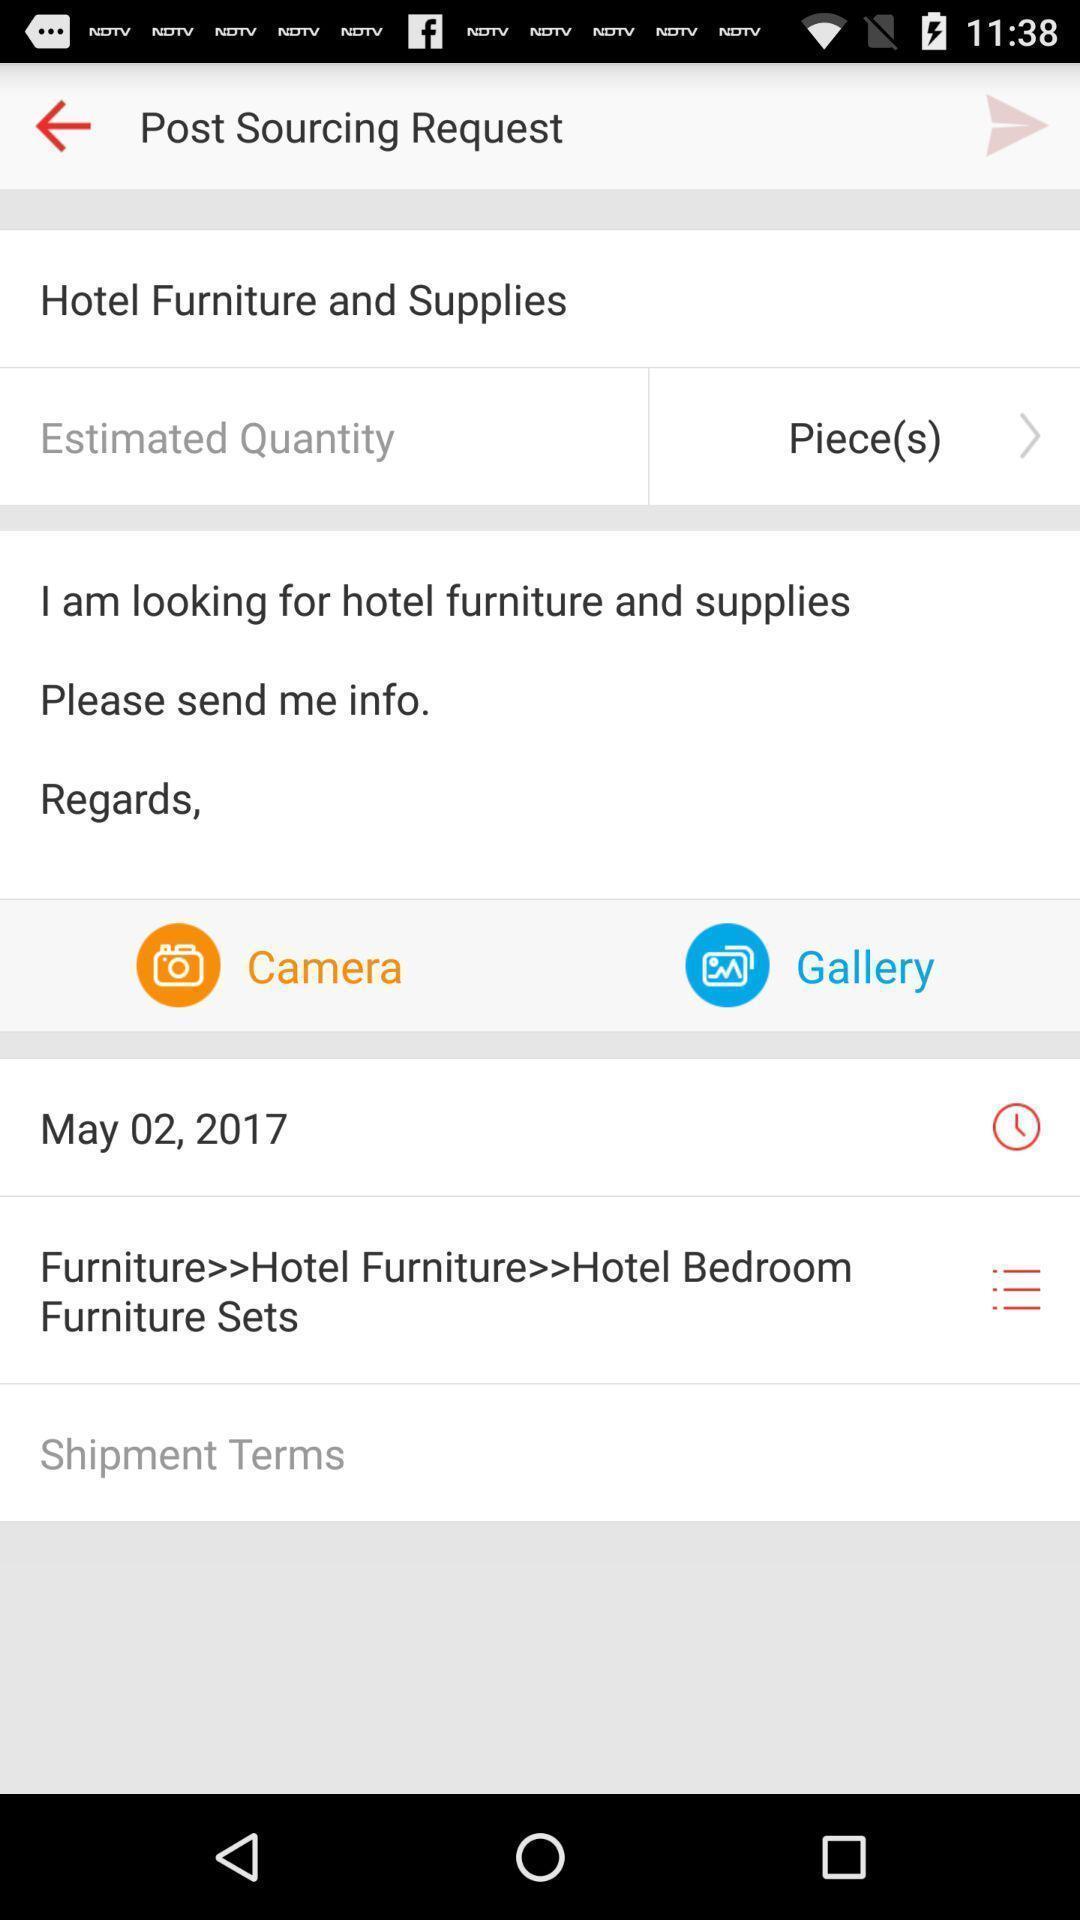Describe this image in words. Screen displaying post sourcing request. 